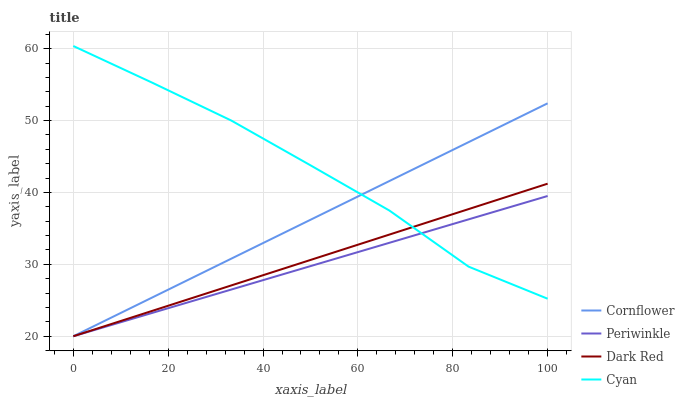Does Periwinkle have the minimum area under the curve?
Answer yes or no. Yes. Does Cyan have the maximum area under the curve?
Answer yes or no. Yes. Does Cyan have the minimum area under the curve?
Answer yes or no. No. Does Periwinkle have the maximum area under the curve?
Answer yes or no. No. Is Dark Red the smoothest?
Answer yes or no. Yes. Is Cyan the roughest?
Answer yes or no. Yes. Is Periwinkle the smoothest?
Answer yes or no. No. Is Periwinkle the roughest?
Answer yes or no. No. Does Cornflower have the lowest value?
Answer yes or no. Yes. Does Cyan have the lowest value?
Answer yes or no. No. Does Cyan have the highest value?
Answer yes or no. Yes. Does Periwinkle have the highest value?
Answer yes or no. No. Does Periwinkle intersect Dark Red?
Answer yes or no. Yes. Is Periwinkle less than Dark Red?
Answer yes or no. No. Is Periwinkle greater than Dark Red?
Answer yes or no. No. 